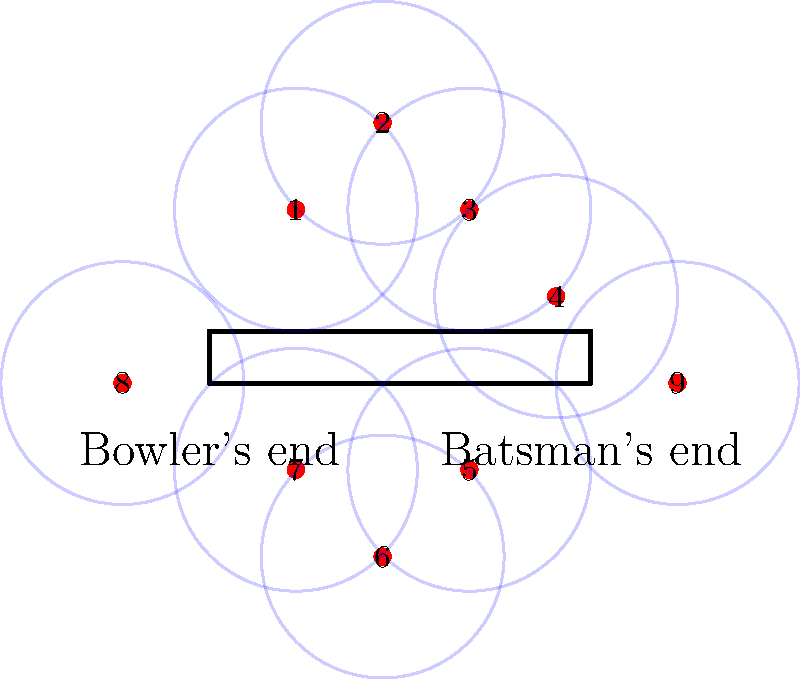In the given cricket field layout, which fielding position should be adjusted to improve coverage in the area between positions 3 and 4, without compromising the overall field setup? To answer this question, we need to analyze the current field layout and identify the areas with less coverage:

1. Observe the fielding positions (1-9) and their respective coverage areas (blue circles).
2. Notice that there is a gap in coverage between positions 3 and 4.
3. To improve coverage in this area, we need to move one of the nearby fielders without leaving other areas vulnerable.
4. Position 2 is the best candidate for adjustment because:
   a. It's close to the area we want to cover.
   b. Moving it slightly won't significantly affect coverage in its current area.
   c. Positions 1 and 3 can still cover most of position 2's original area.
5. By moving position 2 slightly towards the gap between 3 and 4, we can improve coverage without compromising the overall field setup.
6. This adjustment maintains a balanced field while addressing the identified weakness.

The optimal solution is to adjust fielding position 2 to cover the gap between positions 3 and 4.
Answer: Position 2 